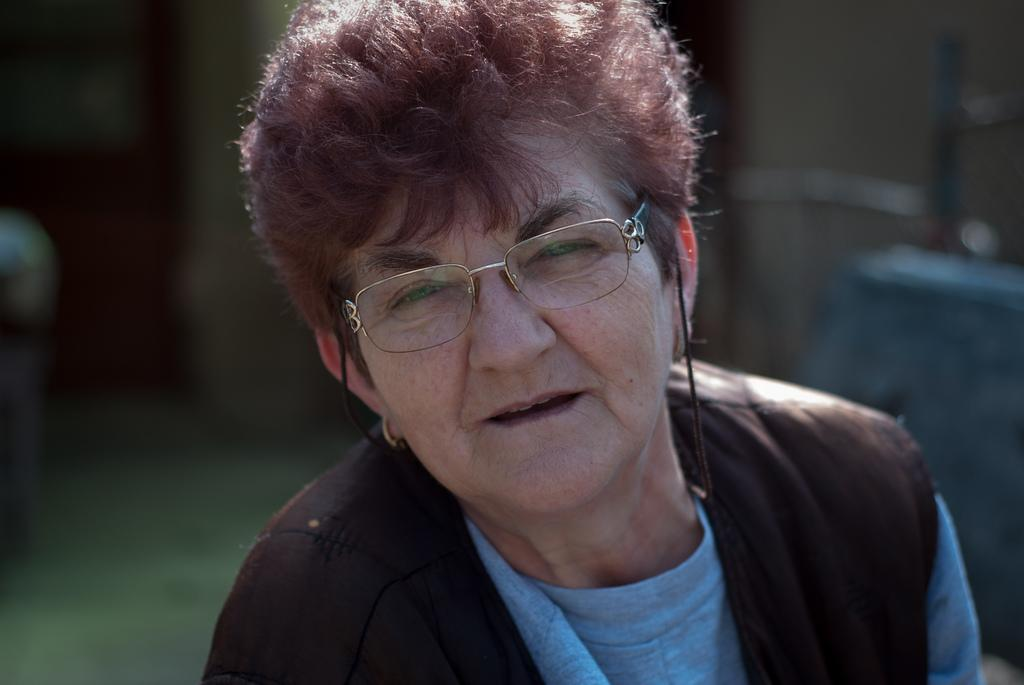What is the main subject of the image? There is a person in the image. Can you describe the background of the image? The background of the image is blurred. What type of appliance is being used to take a bite out of the person's ear in the image? There is: There is no appliance or biting action involving an ear present in the image. 